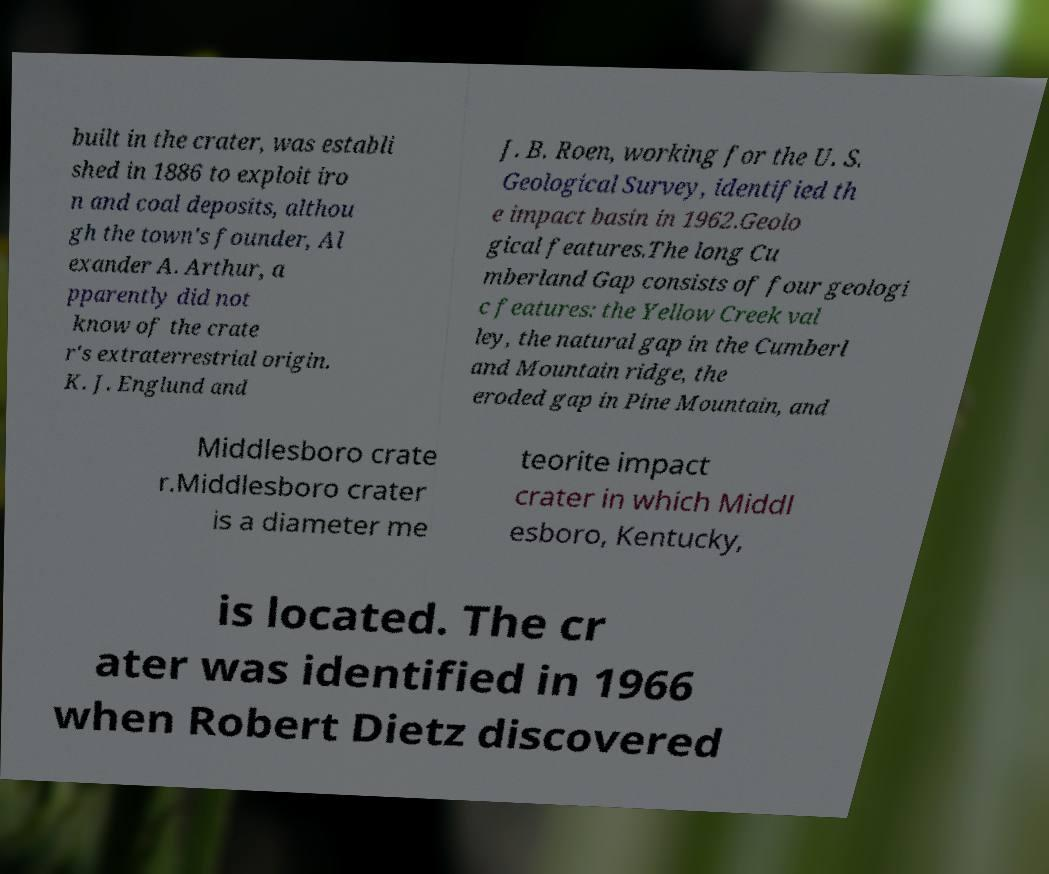There's text embedded in this image that I need extracted. Can you transcribe it verbatim? built in the crater, was establi shed in 1886 to exploit iro n and coal deposits, althou gh the town's founder, Al exander A. Arthur, a pparently did not know of the crate r's extraterrestrial origin. K. J. Englund and J. B. Roen, working for the U. S. Geological Survey, identified th e impact basin in 1962.Geolo gical features.The long Cu mberland Gap consists of four geologi c features: the Yellow Creek val ley, the natural gap in the Cumberl and Mountain ridge, the eroded gap in Pine Mountain, and Middlesboro crate r.Middlesboro crater is a diameter me teorite impact crater in which Middl esboro, Kentucky, is located. The cr ater was identified in 1966 when Robert Dietz discovered 